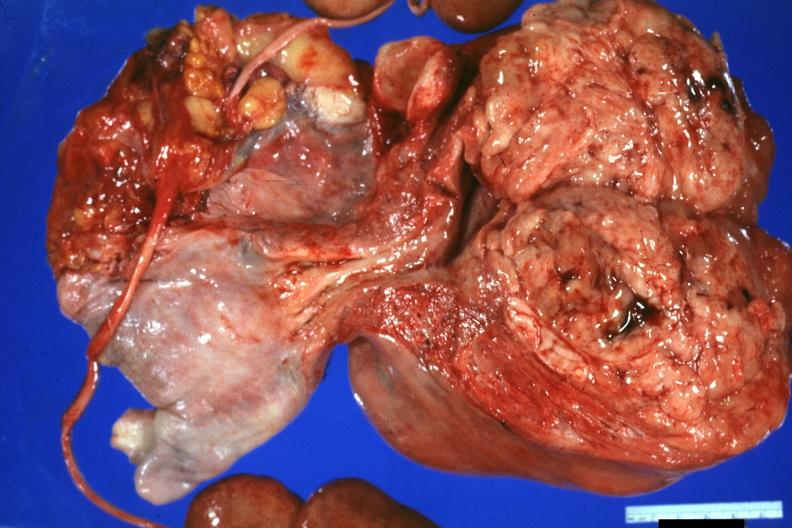where does this part belong to?
Answer the question using a single word or phrase. Female reproductive system 